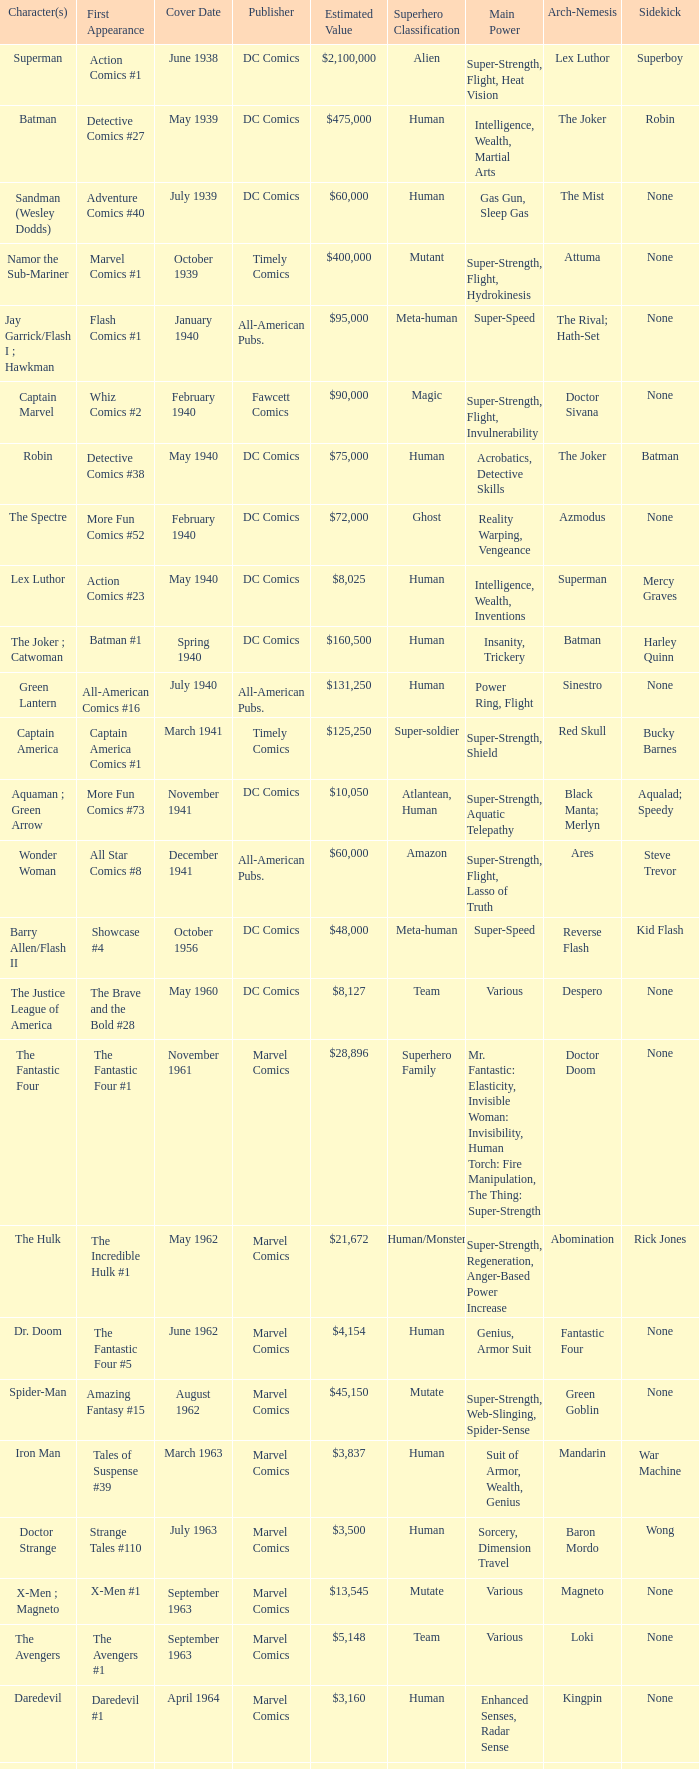What is Action Comics #1's estimated value? $2,100,000. 